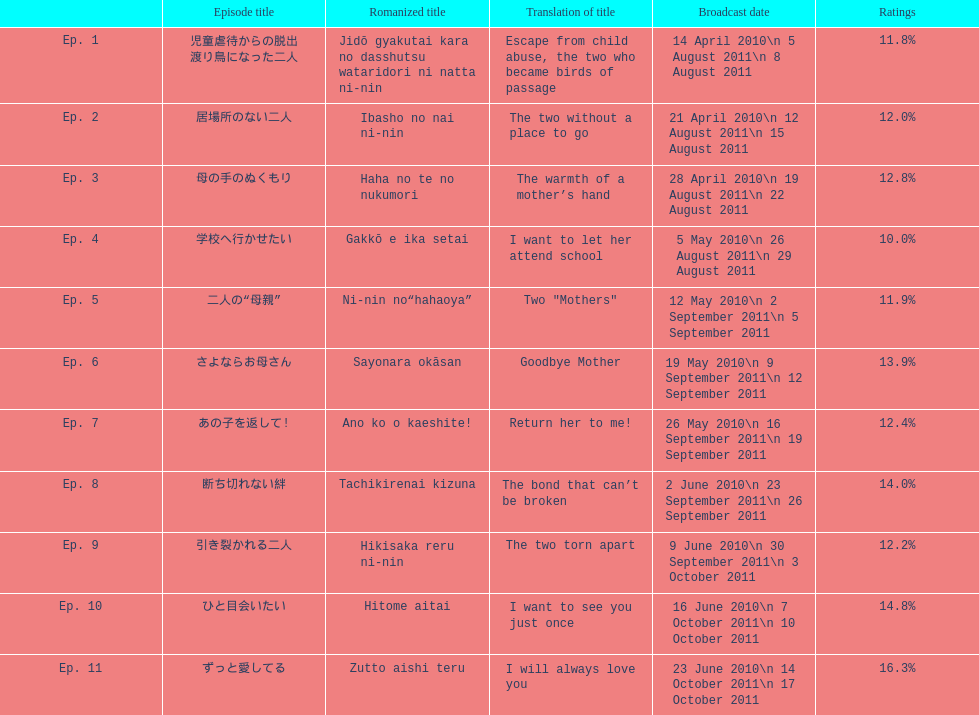How many episode total are there? 11. 